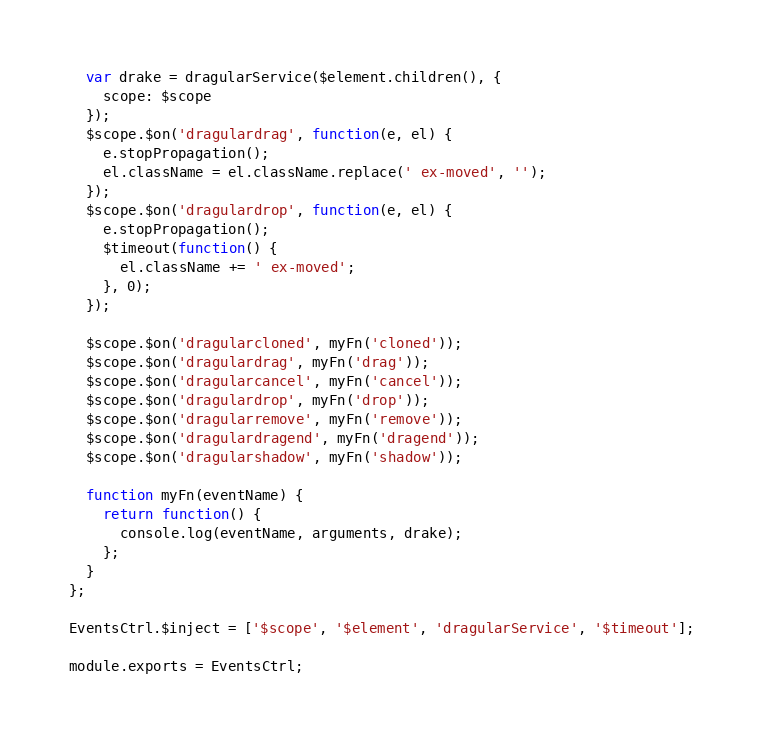Convert code to text. <code><loc_0><loc_0><loc_500><loc_500><_JavaScript_>  var drake = dragularService($element.children(), {
    scope: $scope
  });
  $scope.$on('dragulardrag', function(e, el) {
    e.stopPropagation();
    el.className = el.className.replace(' ex-moved', '');
  });
  $scope.$on('dragulardrop', function(e, el) {
    e.stopPropagation();
    $timeout(function() {
      el.className += ' ex-moved';
    }, 0);
  });

  $scope.$on('dragularcloned', myFn('cloned'));
  $scope.$on('dragulardrag', myFn('drag'));
  $scope.$on('dragularcancel', myFn('cancel'));
  $scope.$on('dragulardrop', myFn('drop'));
  $scope.$on('dragularremove', myFn('remove'));
  $scope.$on('dragulardragend', myFn('dragend'));
  $scope.$on('dragularshadow', myFn('shadow'));

  function myFn(eventName) {
    return function() {
      console.log(eventName, arguments, drake);
    };
  }
};

EventsCtrl.$inject = ['$scope', '$element', 'dragularService', '$timeout'];

module.exports = EventsCtrl;
</code> 